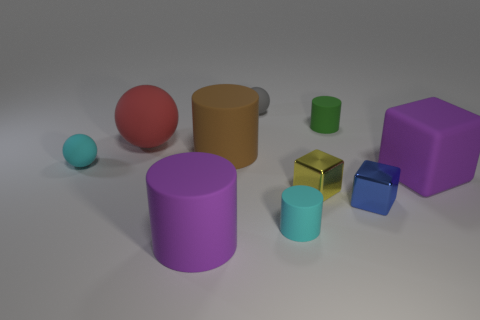There is a large matte block; is it the same color as the matte cylinder on the left side of the big brown thing?
Your answer should be very brief. Yes. There is a rubber cube that is the same size as the red sphere; what color is it?
Offer a terse response. Purple. Are there any big red rubber things behind the purple matte thing that is to the right of the tiny green cylinder?
Make the answer very short. Yes. How many cylinders are blue things or small green objects?
Ensure brevity in your answer.  1. There is a rubber block on the right side of the small rubber ball in front of the small matte thing that is behind the small green matte cylinder; what is its size?
Your response must be concise. Large. There is a green rubber cylinder; are there any purple things right of it?
Your answer should be compact. Yes. The rubber object that is the same color as the matte block is what shape?
Make the answer very short. Cylinder. What number of objects are either objects right of the red rubber ball or big red rubber spheres?
Make the answer very short. 9. There is a cyan sphere that is made of the same material as the small gray ball; what is its size?
Offer a very short reply. Small. There is a yellow metallic cube; does it have the same size as the purple cylinder that is on the right side of the big sphere?
Make the answer very short. No. 